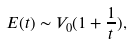Convert formula to latex. <formula><loc_0><loc_0><loc_500><loc_500>E ( t ) \sim V _ { 0 } ( 1 + \frac { 1 } { t } ) ,</formula> 